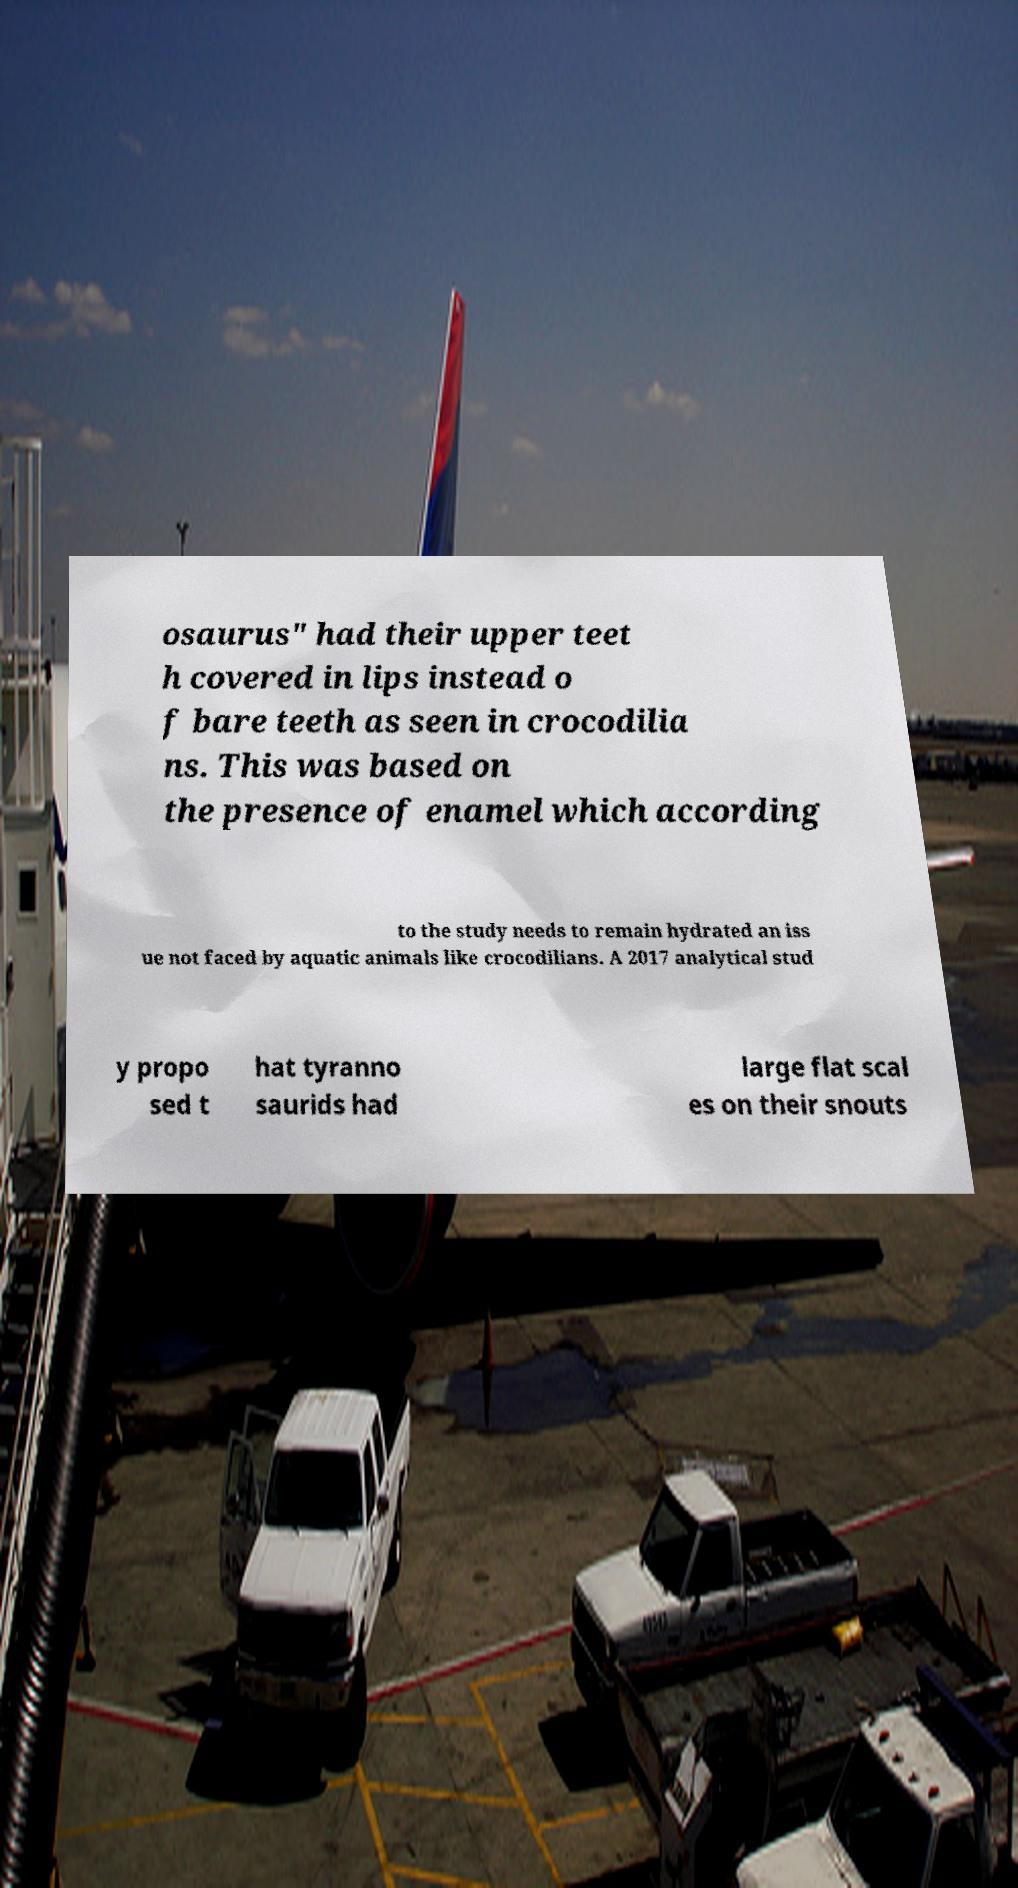There's text embedded in this image that I need extracted. Can you transcribe it verbatim? osaurus" had their upper teet h covered in lips instead o f bare teeth as seen in crocodilia ns. This was based on the presence of enamel which according to the study needs to remain hydrated an iss ue not faced by aquatic animals like crocodilians. A 2017 analytical stud y propo sed t hat tyranno saurids had large flat scal es on their snouts 